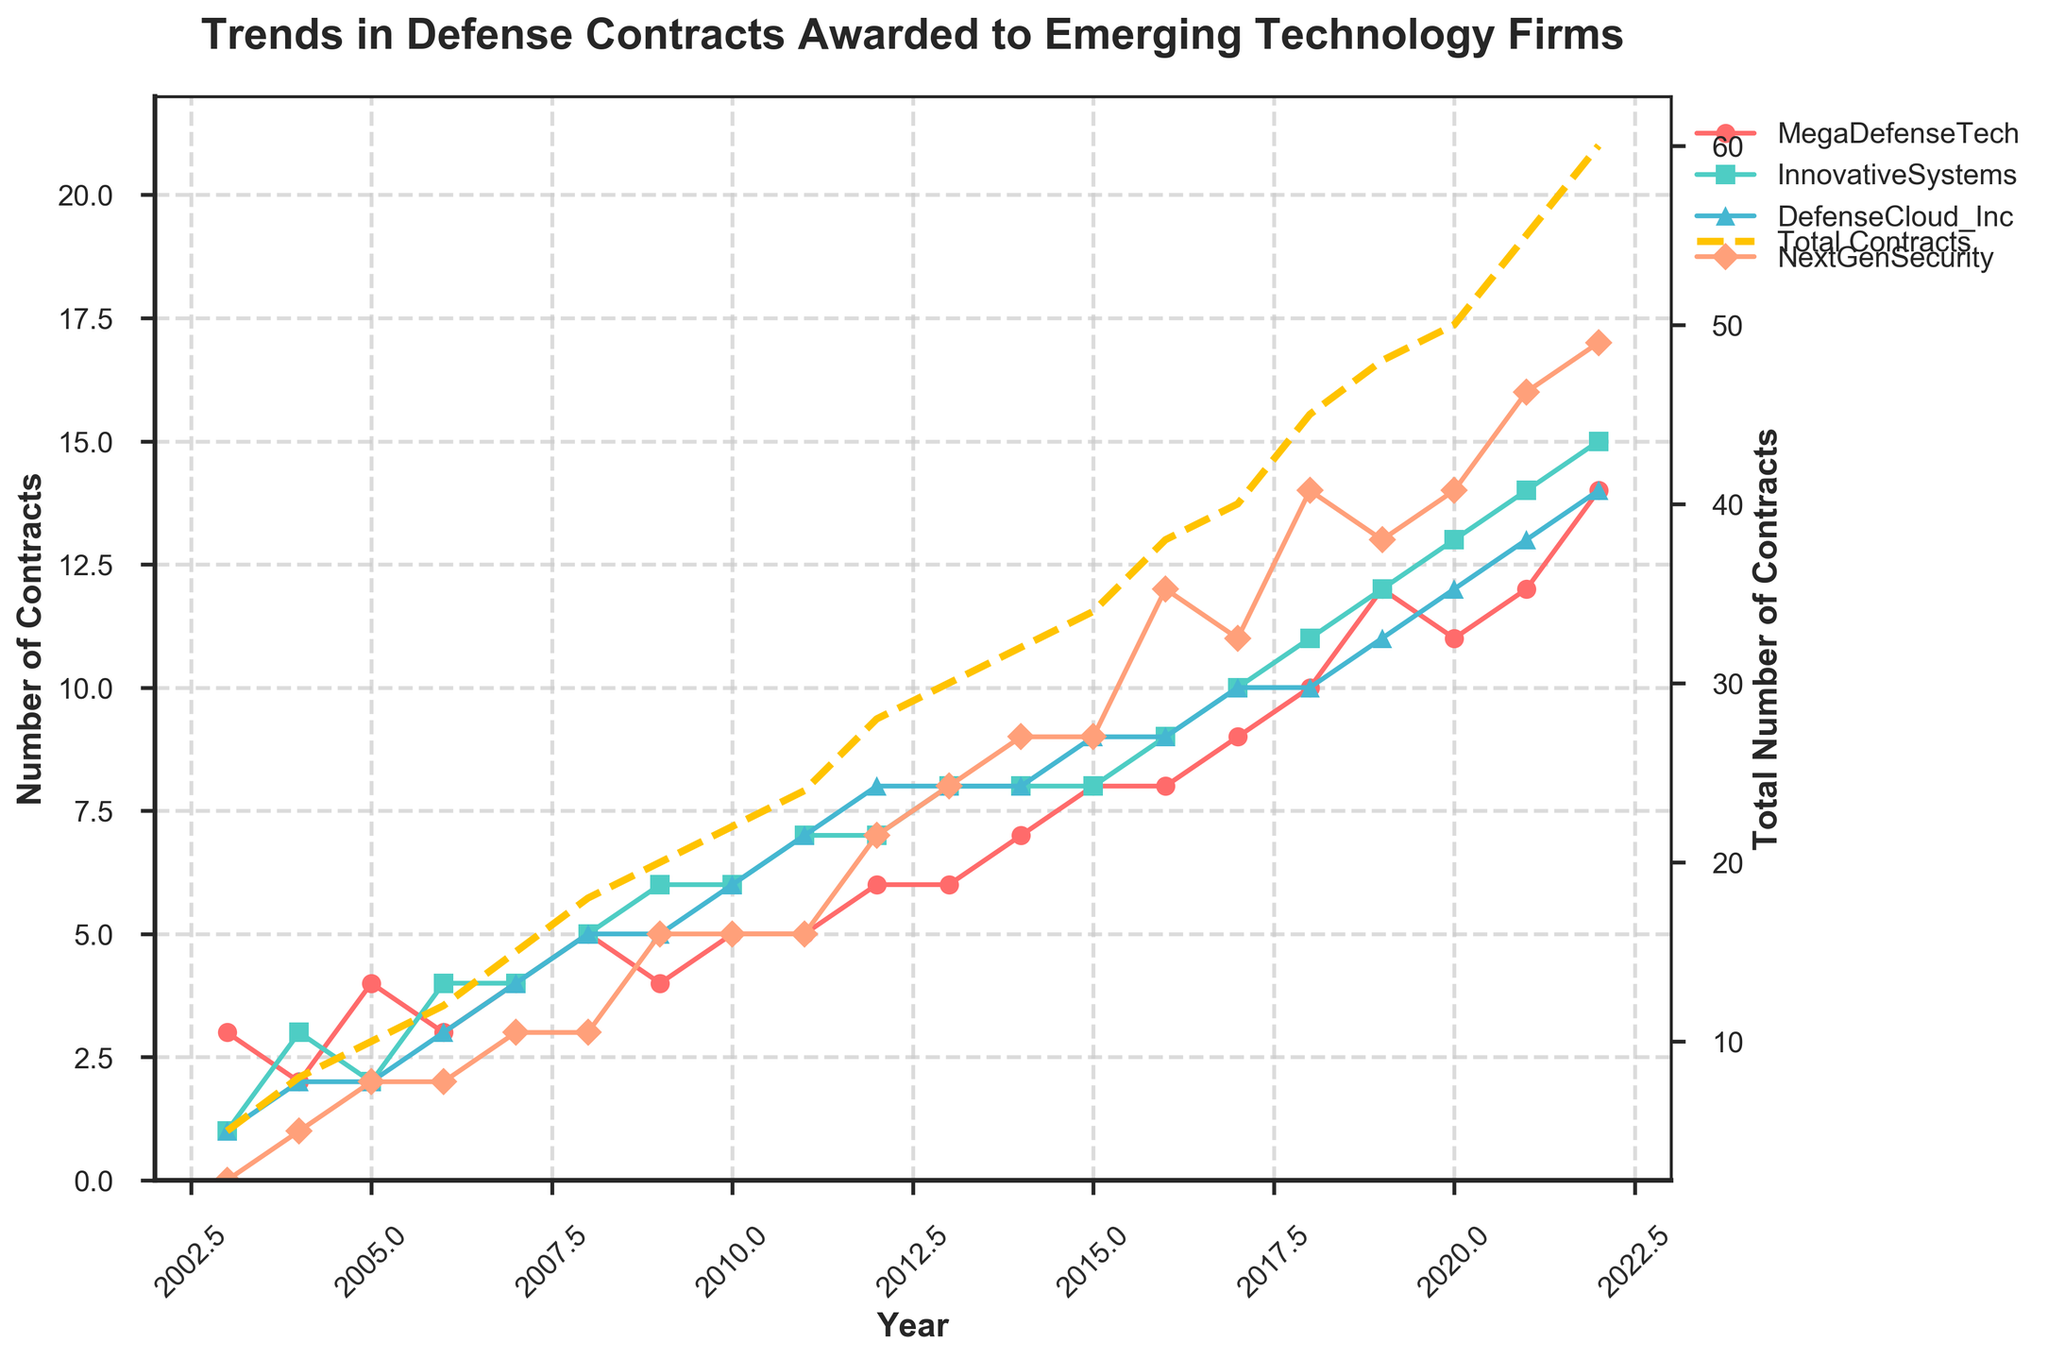What is the title of the figure? The title of the figure is located at the top of the plot, typically in bold font. It usually provides a summary of what the figure is about.
Answer: Trends in Defense Contracts Awarded to Emerging Technology Firms Which company had the highest number of contracts in 2022? To find the highest number of contracts for each company in 2022, look at the specific year on the x-axis and compare the y-values for all companies.
Answer: NextGenSecurity How many total defense contracts were awarded in 2013? This can be found by looking at the secondary y-axis labeled 'Total Number of Contracts' and following the line for the year 2013.
Answer: 30 Between MegaDefenseTech and DefenseCloud_Inc, which company had more contracts in 2010, and by how many? By examining the y-values for each company in 2010, we can compare them and subtract the smaller value from the larger value. MegaDefenseTech had 5 and DefenseCloud_Inc had 6.
Answer: DefenseCloud_Inc by 1 What is the overall trend observed in the total number of contracts awarded from 2003 to 2022? To determine the trend, look at the overall slope and direction of the line representing the total number of contracts. The line appears to continually increase over time.
Answer: Increasing trend Which company experienced the most significant growth in the number of contracts from 2003 to 2022? By comparing the total increase in the number of contracts for each company over this time period and identifying which has the largest difference between their 2003 and 2022 values.
Answer: NextGenSecurity In which year did InnovativeSystems surpass the number of contracts awarded to MegaDefenseTech? Identify the year where the y-value for InnovativeSystems first exceeds the y-value for MegaDefenseTech. This can be visually verified by looking at the intersection points.
Answer: 2022 What is the difference between the total number of contracts awarded in 2008 and 2018? Find the total number of contracts for each of those years on the secondary y-axis and take the difference. The values are 18 for 2008 and 45 for 2018.
Answer: 27 Looking at the trends, which company had the most consistent growth in the number of contracts awarded over the 20 years? Consistent growth can be identified by finding the company with the least variability and steadiest upward slope in its line.
Answer: MegaDefenseTech 